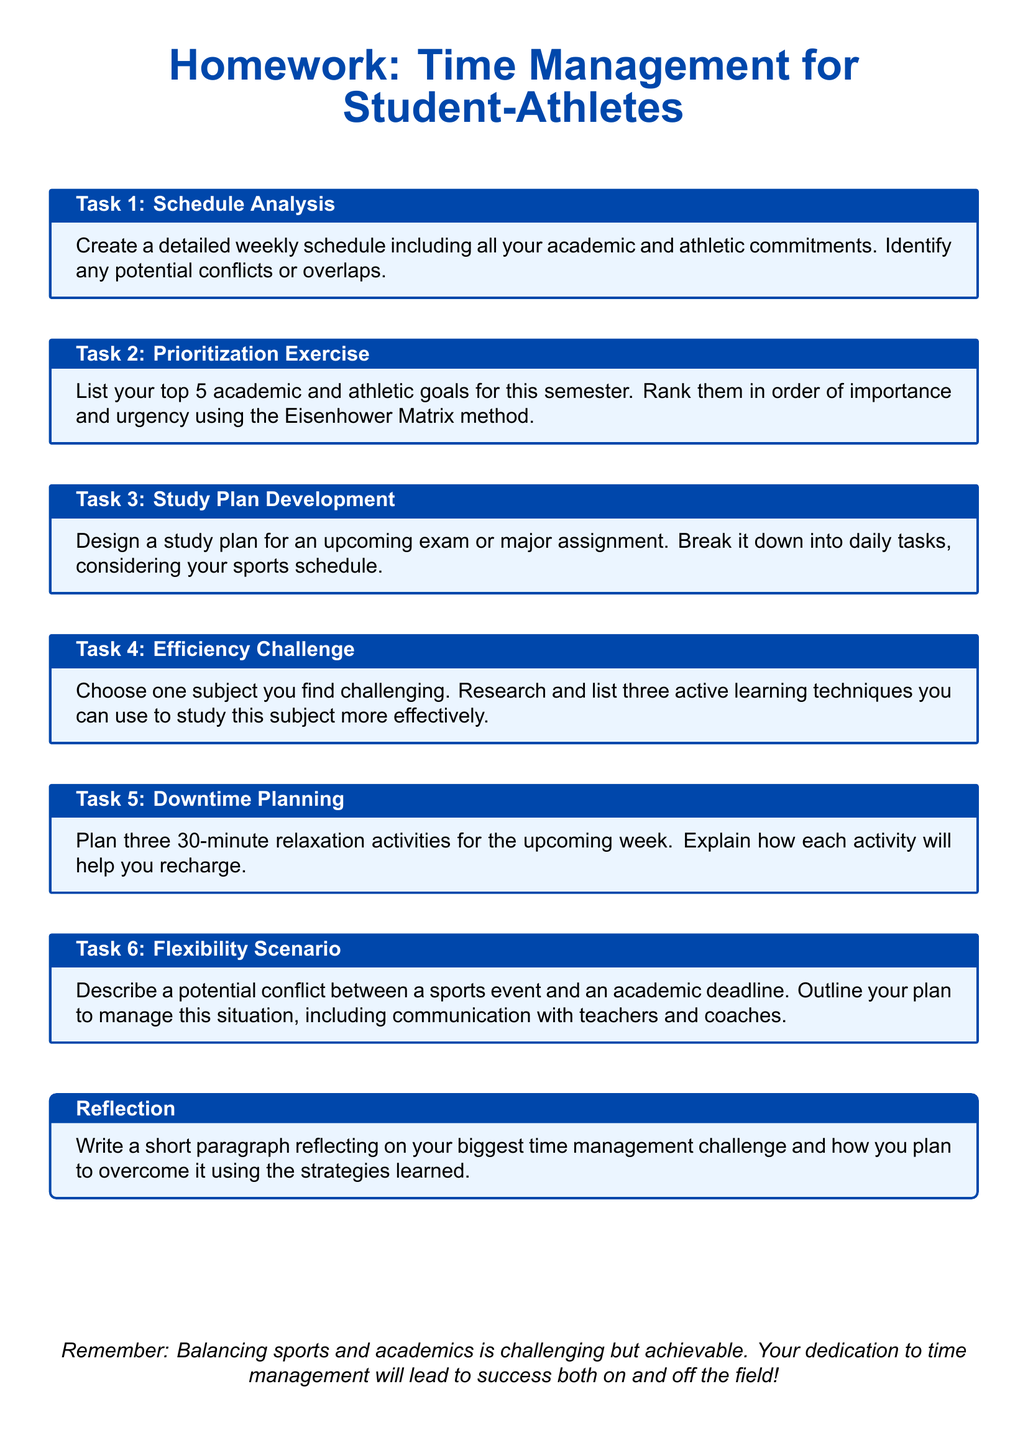What is the main title of the homework? The title provides the focus of the document and is prominently displayed at the top.
Answer: Homework: Time Management for Student-Athletes How many tasks are listed in the document? The number of tasks can be counted from the sections presented.
Answer: 6 What is the title of Task 3? The titles of tasks are indicated in the boxes, showing what needs to be done.
Answer: Study Plan Development What is one of the goals of Task 5? Task 5 asks for specific activities aimed at relaxation, which contribute to managing stress.
Answer: Plan three 30-minute relaxation activities Which matrix is used in Task 2 for prioritization? The matrix mentioned in Task 2 is a specific method for organizing tasks based on importance and urgency.
Answer: Eisenhower Matrix What is addressed in the Reflection section? This section prompts the writer to consider their personal challenges with time management.
Answer: Biggest time management challenge What is an overarching theme of the document? The document suggests a general aim for the student-athletes' approach to their commitments.
Answer: Balancing sports and academics What will the activities in Task 5 help the student-athlete do? The task encourages planning activities that are aimed at mental and physical rejuvenation.
Answer: Recharge 